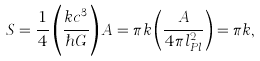Convert formula to latex. <formula><loc_0><loc_0><loc_500><loc_500>S = \frac { 1 } { 4 } \left ( \frac { k c ^ { 3 } } { \hbar { G } } \right ) A = \pi k \left ( \frac { A } { 4 \pi l ^ { 2 } _ { P l } } \right ) = \pi k ,</formula> 